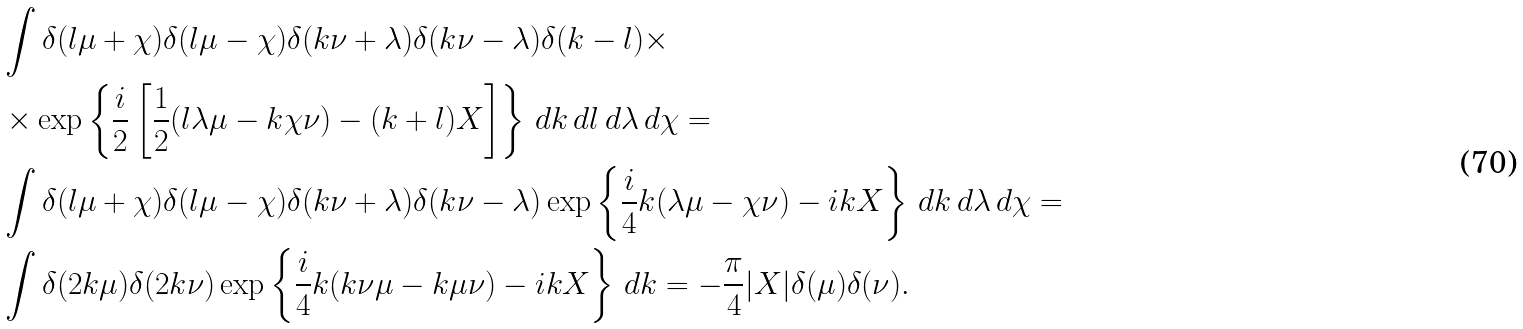<formula> <loc_0><loc_0><loc_500><loc_500>& \int \delta ( l \mu + \chi ) \delta ( l \mu - \chi ) \delta ( k \nu + \lambda ) \delta ( k \nu - \lambda ) \delta ( k - l ) \times \\ & \times \exp \left \{ \frac { i } { 2 } \left [ \frac { 1 } { 2 } ( l \lambda \mu - k \chi \nu ) - ( k + l ) X \right ] \right \} \, d k \, d l \, d \lambda \, d \chi = \\ & \int \delta ( l \mu + \chi ) \delta ( l \mu - \chi ) \delta ( k \nu + \lambda ) \delta ( k \nu - \lambda ) \exp \left \{ \frac { i } { 4 } k ( \lambda \mu - \chi \nu ) - i k X \right \} \, d k \, d \lambda \, d \chi = \\ & \int \delta ( 2 k \mu ) \delta ( 2 k \nu ) \exp \left \{ \frac { i } { 4 } k ( k \nu \mu - k \mu \nu ) - i k X \right \} \, d k = - \frac { \pi } { 4 } | X | \delta ( \mu ) \delta ( \nu ) .</formula> 